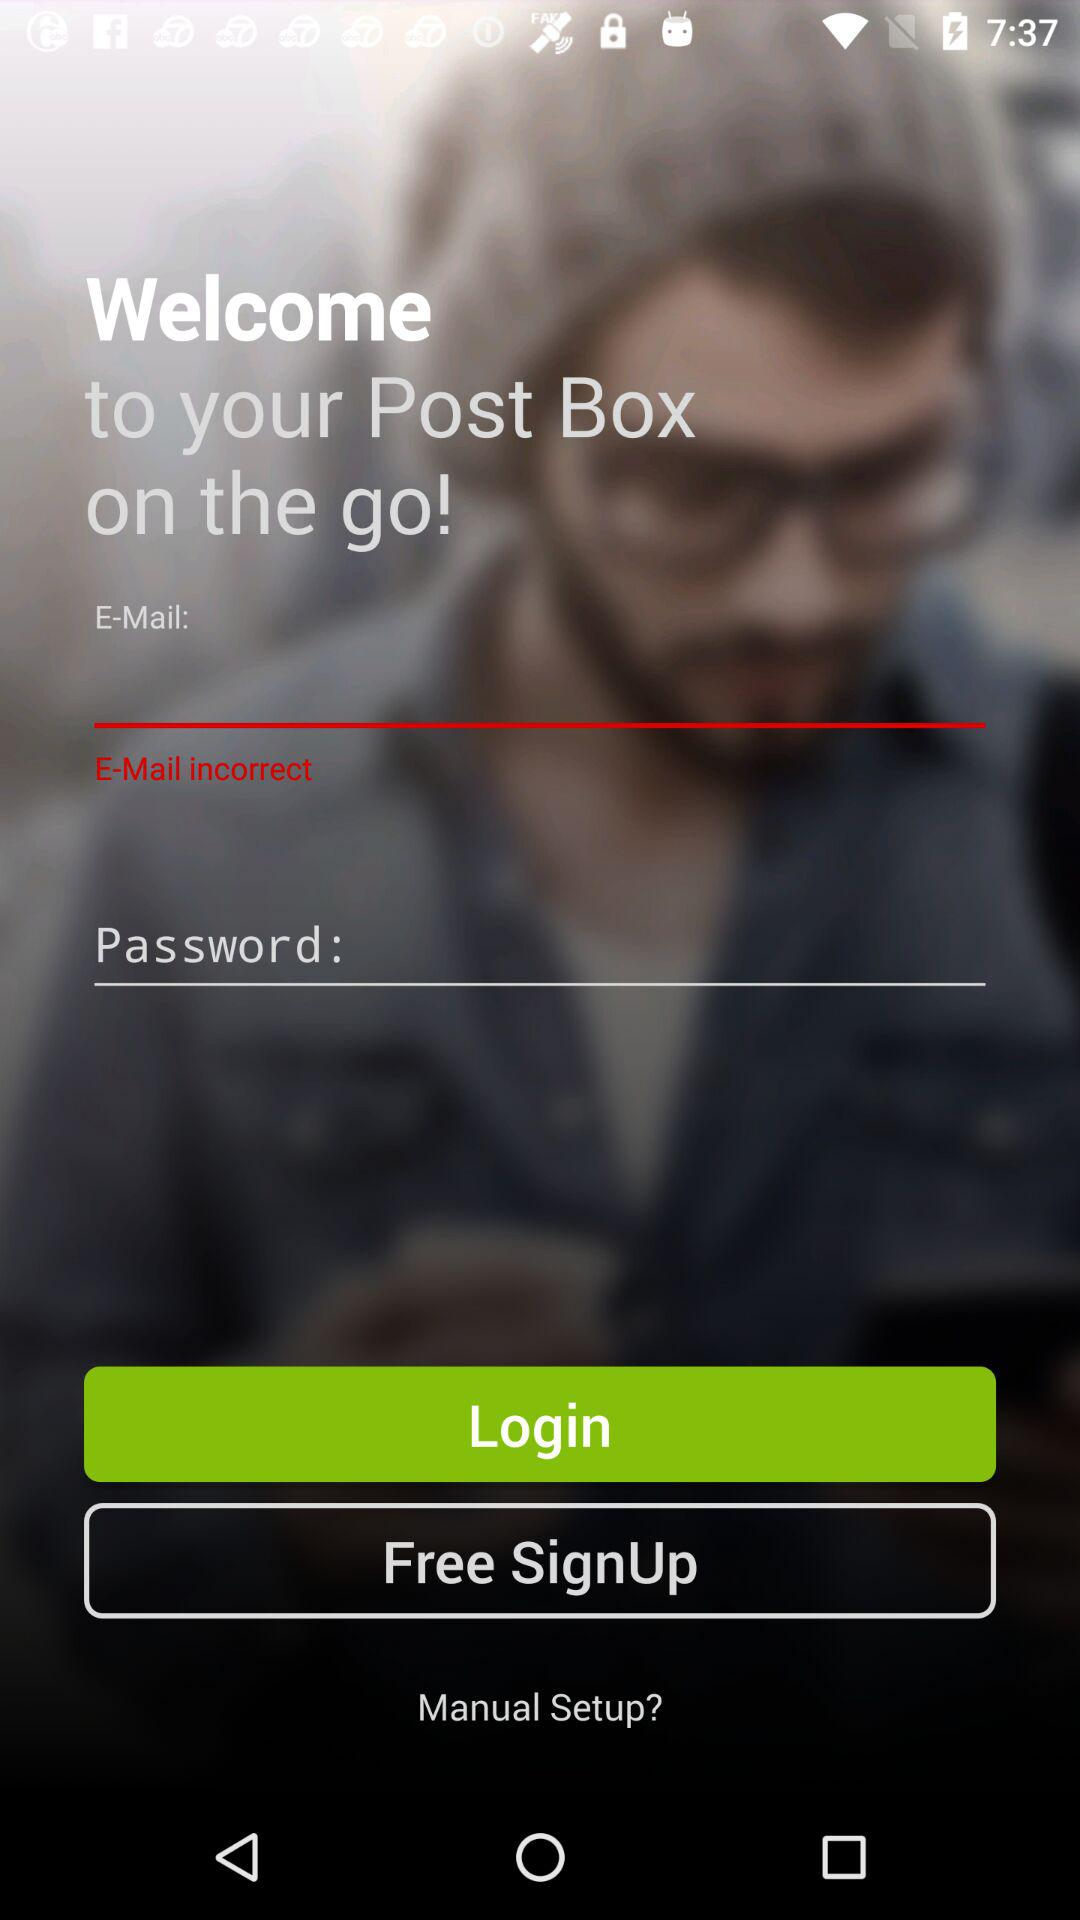How can we log in? You can log in with "E-Mail" and "Password". 